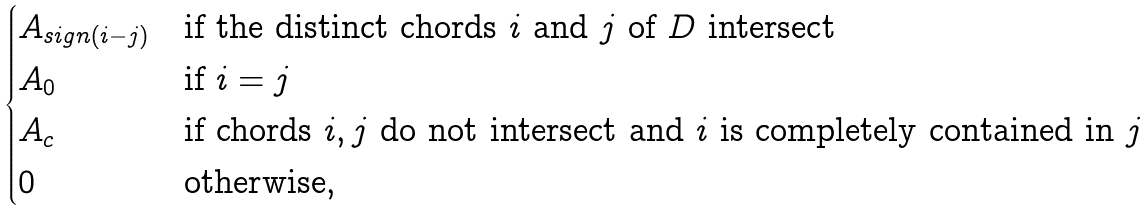<formula> <loc_0><loc_0><loc_500><loc_500>\begin{cases} A _ { s i g n ( i - j ) } & \text {if the distinct     chords $i$ and $j$ of $D$ intersect} \\ A _ { 0 } & \text {if $i=j$} \\ A _ { c } & \text {if chords $i,j$ do not intersect and $i$ is completely contained in $j$} \\ 0 & \text {otherwise} , \end{cases}</formula> 